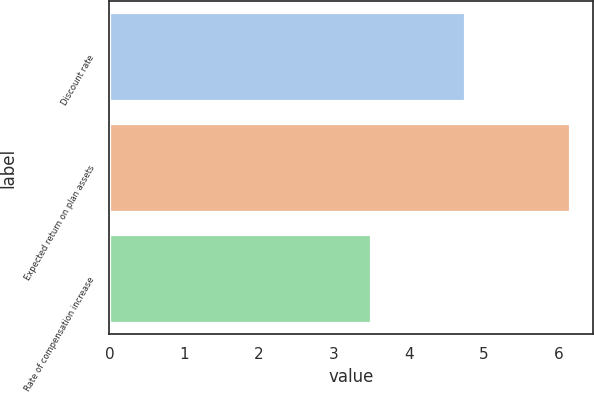Convert chart to OTSL. <chart><loc_0><loc_0><loc_500><loc_500><bar_chart><fcel>Discount rate<fcel>Expected return on plan assets<fcel>Rate of compensation increase<nl><fcel>4.75<fcel>6.15<fcel>3.5<nl></chart> 